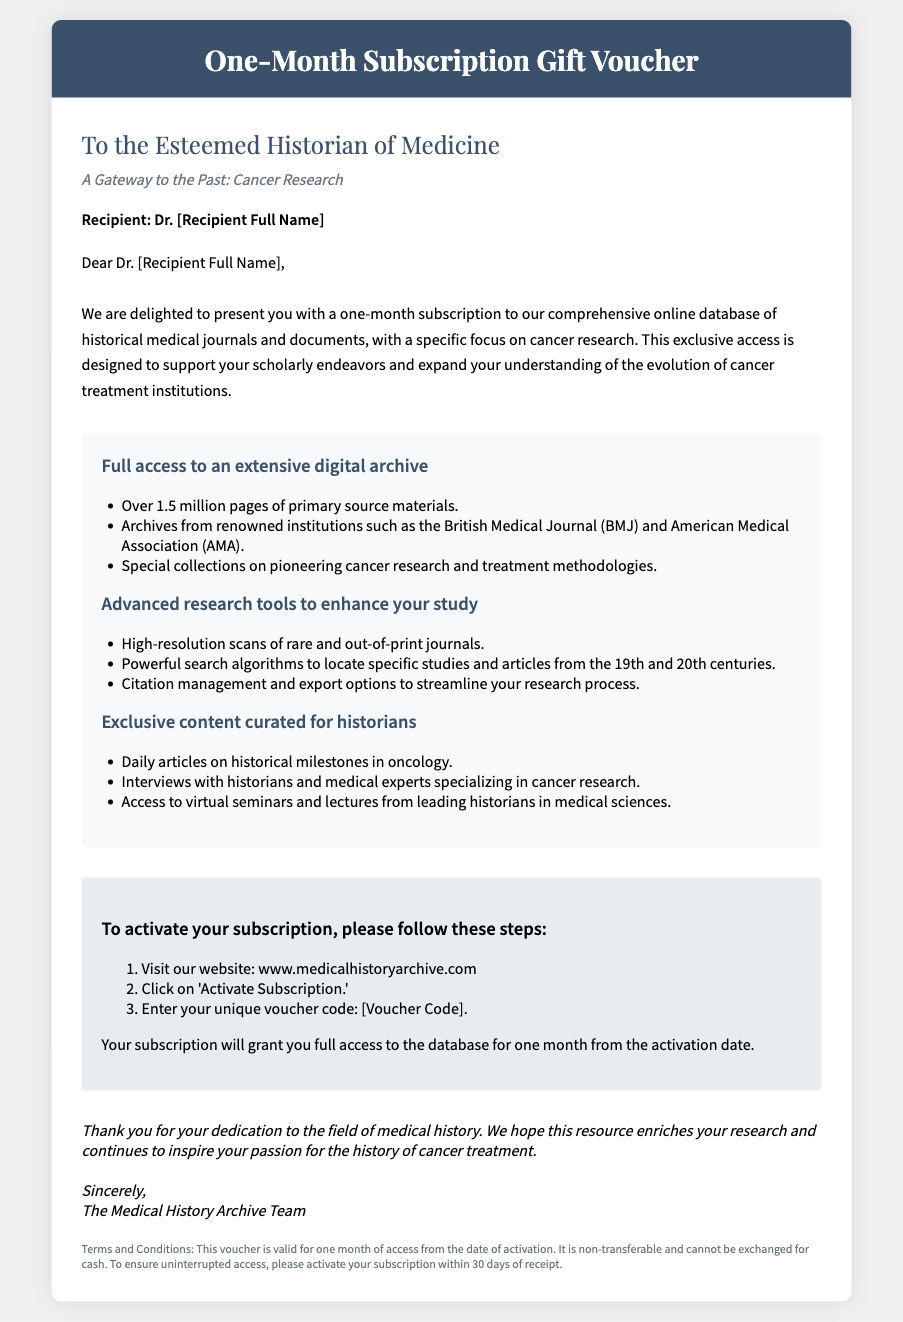What is the title of the voucher? The title is prominently displayed at the top of the document, which is "One-Month Subscription Gift Voucher."
Answer: One-Month Subscription Gift Voucher Who is the voucher addressed to? The recipient's name is mentioned in the document, indicated by "Recipient: Dr. [Recipient Full Name]."
Answer: Dr. [Recipient Full Name] How many pages of primary source materials does the database offer? The document states there are "Over 1.5 million pages of primary source materials."
Answer: Over 1.5 million pages What is the website to activate the subscription? The document provides the website as "www.medicalhistoryarchive.com."
Answer: www.medicalhistoryarchive.com How many steps are listed to activate the subscription? The instructions outline "3 steps" to activate the subscription.
Answer: 3 steps What type of content will be exclusive to historians? The document mentions "Daily articles on historical milestones in oncology" as exclusive content.
Answer: Daily articles on historical milestones in oncology What is the validity period of the voucher after activation? The terms indicate that the voucher is valid for "one month of access from the date of activation."
Answer: one month What is the background color of the voucher header? The header background color specified in the document is "#3a506b."
Answer: #3a506b What is mentioned at the end of the letter? The closing part of the document expresses gratitude and is signed off by "The Medical History Archive Team."
Answer: The Medical History Archive Team 